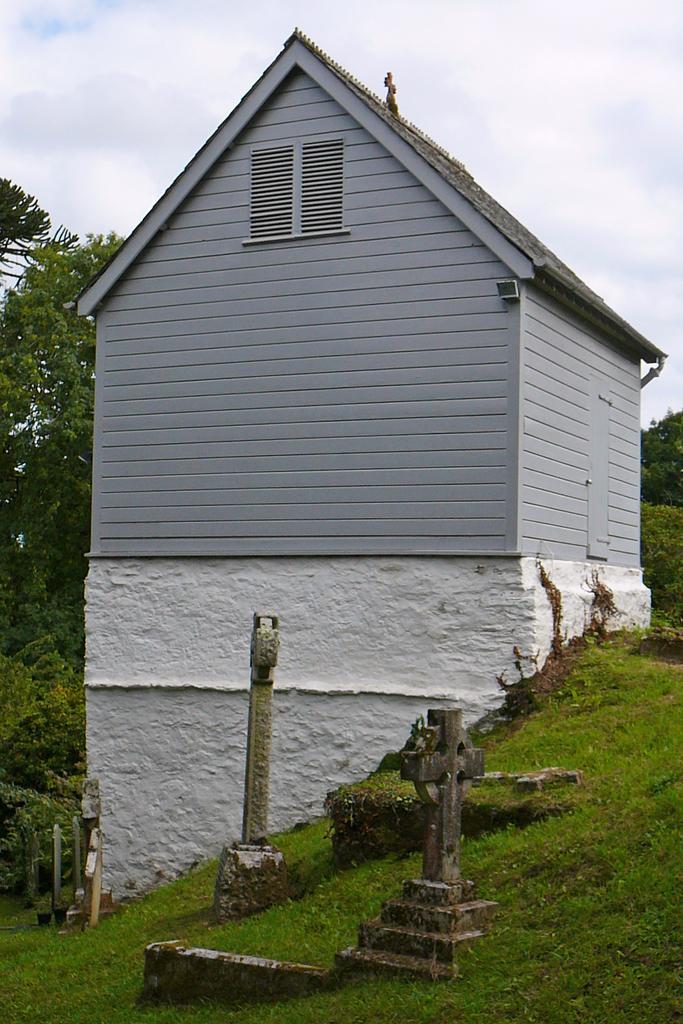Can you describe this image briefly? In this image we can see a shed, grass, trees, and objects. In the background there is sky with clouds. 